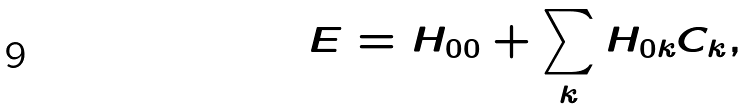<formula> <loc_0><loc_0><loc_500><loc_500>E = H _ { 0 0 } + \sum _ { k } H _ { 0 k } C _ { k } ,</formula> 